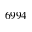<formula> <loc_0><loc_0><loc_500><loc_500>6 9 9 4</formula> 